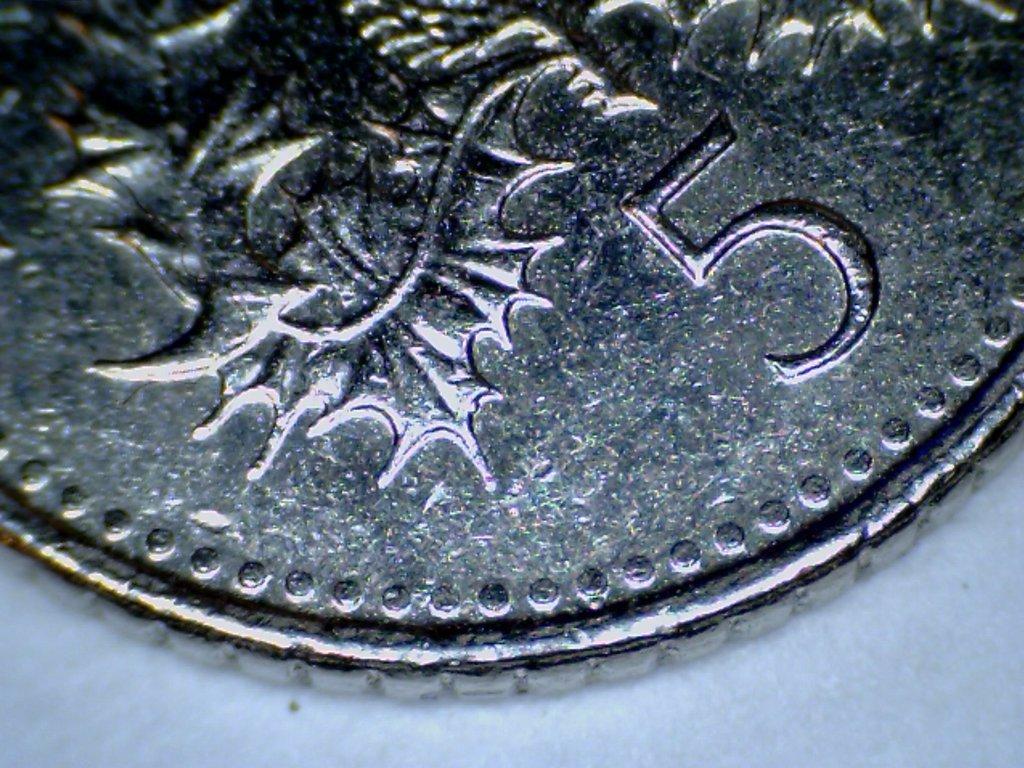How would you summarize this image in a sentence or two? In this image, we can see a coin on the table. 